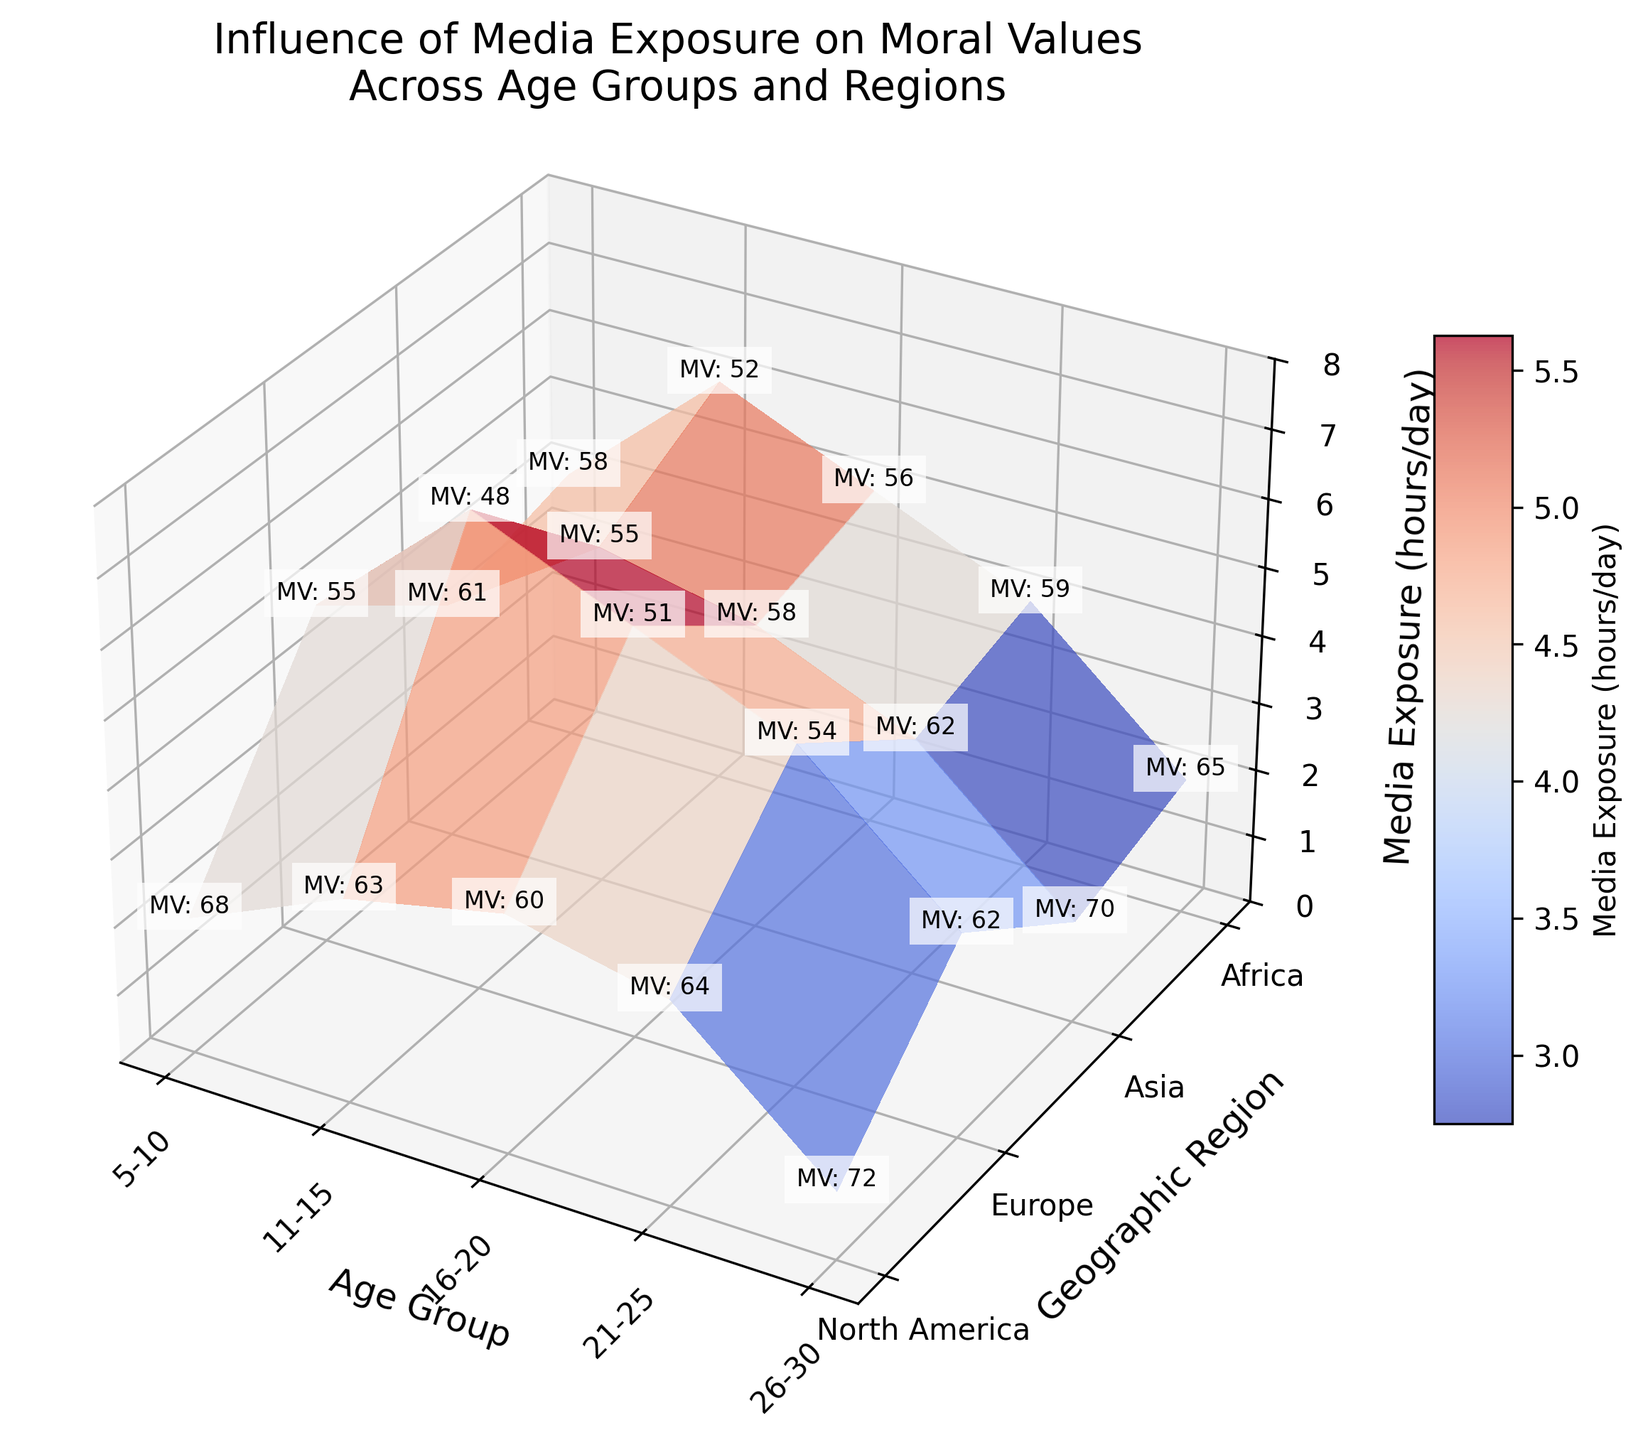How many age groups are depicted in the figure? The figure shows the x-axis labeled as "Age Group," with ticks and labels denoting each age group. Counting these labeled ticks reveals the total number of age groups.
Answer: 5 What is the title of the plot? The title of the plot is located at the top of the figure.
Answer: Influence of Media Exposure on Moral Values Across Age Groups and Regions In which age group does North America have the highest media exposure? To determine this, observe the Z-axis value (Media Exposure hours/day) specific to North America across all age groups and identify the highest value.
Answer: 16-20 Which geographic region has the lowest moral values score in the 16-20 age group? Check the text annotations on the surface plot for the age group 16-20 and identify the region with the lowest "MV" value.
Answer: Asia Across all age groups, which region shows the least variation in media exposure hours? By observing the surface plot along the Y-axis (Geographic Region) and examining the surface's Z-values (Media Exposure hours/day) across age groups, identify the region with the least fluctuation in Z-values.
Answer: Africa What is the media exposure in hours/day for Europe in the age group 26-30 and its corresponding moral values score? Locate the intersection of Europe and the age group 26-30 on the plot. Refer to the Z-axis for Media Exposure and the text annotation for the Moral Values Score.
Answer: 3.5 hours/day, MV: 62 How does the media exposure for the age group 11-15 in Africa compare to that in Asia? Compare the Z-values (Media Exposure hours/day) on the surface plot for the age group 11-15 across Africa and Asia.
Answer: Africa has lower exposure On average, which age group has the highest media exposure hours per day? Average the Z-values (Media Exposure hours/day) across all regions for each age group and identify the age group with the highest average.
Answer: 16-20 If we consider moral values scores, which age group seems least affected by media exposure across all regions? Analyze the text annotations indicating "MV" values; identify the age group with the highest moral values scores across regions, suggesting least impact.
Answer: 5-10 Is there a visible trend in moral values scores as media exposure increases for the age group 21-25? Examine the text annotations for moral values scores and Z-values (Media Exposure hours/day) for age group 21-25 across all regions to identify any trend.
Answer: Moral values tend to decrease 